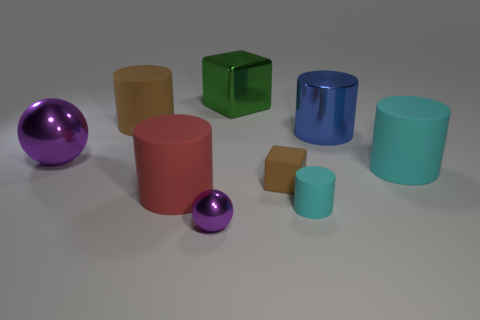Subtract all big cyan cylinders. How many cylinders are left? 4 Subtract 1 balls. How many balls are left? 1 Subtract all large metal cubes. Subtract all metal cylinders. How many objects are left? 7 Add 1 large blue metal things. How many large blue metal things are left? 2 Add 5 metallic blocks. How many metallic blocks exist? 6 Subtract all cyan cylinders. How many cylinders are left? 3 Subtract 0 gray cubes. How many objects are left? 9 Subtract all spheres. How many objects are left? 7 Subtract all purple cylinders. Subtract all brown balls. How many cylinders are left? 5 Subtract all green blocks. How many cyan cylinders are left? 2 